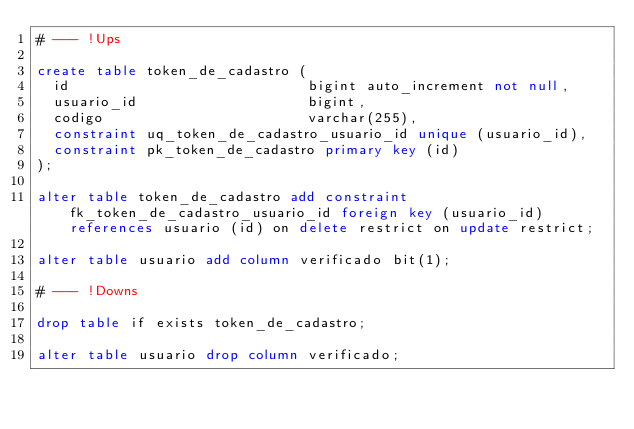Convert code to text. <code><loc_0><loc_0><loc_500><loc_500><_SQL_># --- !Ups

create table token_de_cadastro (
  id                            bigint auto_increment not null,
  usuario_id                    bigint,
  codigo		                varchar(255),
  constraint uq_token_de_cadastro_usuario_id unique (usuario_id),
  constraint pk_token_de_cadastro primary key (id)
);

alter table token_de_cadastro add constraint fk_token_de_cadastro_usuario_id foreign key (usuario_id) references usuario (id) on delete restrict on update restrict;

alter table usuario add column verificado bit(1);

# --- !Downs

drop table if exists token_de_cadastro;

alter table usuario drop column verificado;

</code> 